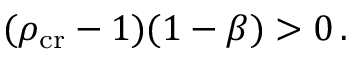Convert formula to latex. <formula><loc_0><loc_0><loc_500><loc_500>( \rho _ { c r } - 1 ) ( 1 - \beta ) > 0 \, .</formula> 